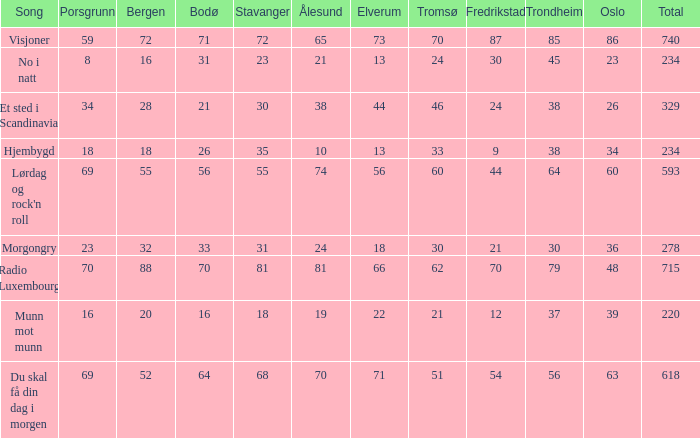What is the smallest aggregate? 220.0. 